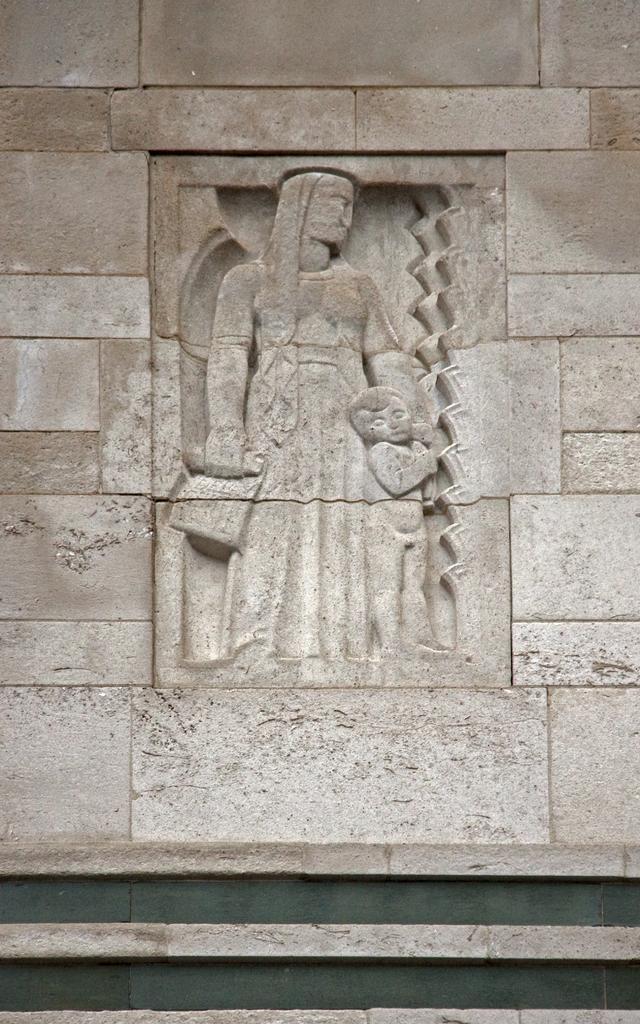Could you give a brief overview of what you see in this image? In this image there is a wall having sculptures of a person and a kid are standing. 